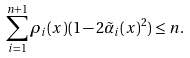Convert formula to latex. <formula><loc_0><loc_0><loc_500><loc_500>\sum _ { i = 1 } ^ { n + 1 } \rho _ { i } ( x ) ( 1 - 2 \tilde { \alpha } _ { i } ( x ) ^ { 2 } ) & \leq n .</formula> 